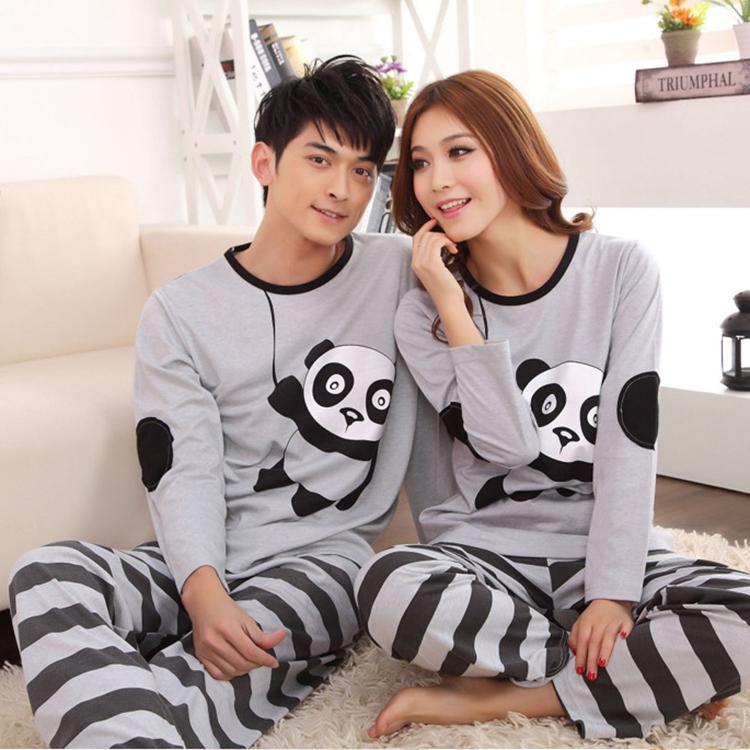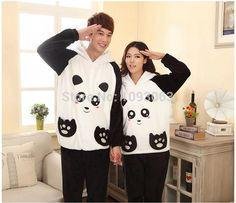The first image is the image on the left, the second image is the image on the right. Evaluate the accuracy of this statement regarding the images: "Each image contains a man and a woman wearing matching clothing.". Is it true? Answer yes or no. Yes. The first image is the image on the left, the second image is the image on the right. For the images displayed, is the sentence "In one of the image the woman has her hood pulled up." factually correct? Answer yes or no. No. 